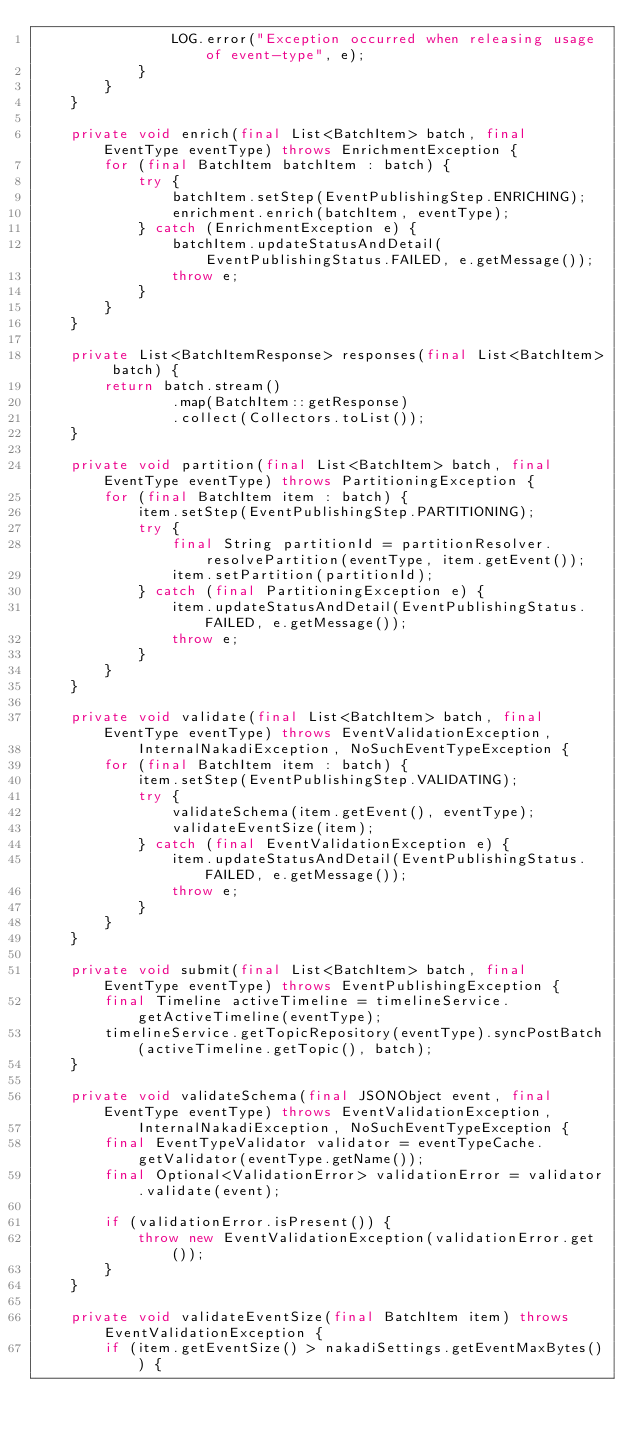Convert code to text. <code><loc_0><loc_0><loc_500><loc_500><_Java_>                LOG.error("Exception occurred when releasing usage of event-type", e);
            }
        }
    }

    private void enrich(final List<BatchItem> batch, final EventType eventType) throws EnrichmentException {
        for (final BatchItem batchItem : batch) {
            try {
                batchItem.setStep(EventPublishingStep.ENRICHING);
                enrichment.enrich(batchItem, eventType);
            } catch (EnrichmentException e) {
                batchItem.updateStatusAndDetail(EventPublishingStatus.FAILED, e.getMessage());
                throw e;
            }
        }
    }

    private List<BatchItemResponse> responses(final List<BatchItem> batch) {
        return batch.stream()
                .map(BatchItem::getResponse)
                .collect(Collectors.toList());
    }

    private void partition(final List<BatchItem> batch, final EventType eventType) throws PartitioningException {
        for (final BatchItem item : batch) {
            item.setStep(EventPublishingStep.PARTITIONING);
            try {
                final String partitionId = partitionResolver.resolvePartition(eventType, item.getEvent());
                item.setPartition(partitionId);
            } catch (final PartitioningException e) {
                item.updateStatusAndDetail(EventPublishingStatus.FAILED, e.getMessage());
                throw e;
            }
        }
    }

    private void validate(final List<BatchItem> batch, final EventType eventType) throws EventValidationException,
            InternalNakadiException, NoSuchEventTypeException {
        for (final BatchItem item : batch) {
            item.setStep(EventPublishingStep.VALIDATING);
            try {
                validateSchema(item.getEvent(), eventType);
                validateEventSize(item);
            } catch (final EventValidationException e) {
                item.updateStatusAndDetail(EventPublishingStatus.FAILED, e.getMessage());
                throw e;
            }
        }
    }

    private void submit(final List<BatchItem> batch, final EventType eventType) throws EventPublishingException {
        final Timeline activeTimeline = timelineService.getActiveTimeline(eventType);
        timelineService.getTopicRepository(eventType).syncPostBatch(activeTimeline.getTopic(), batch);
    }

    private void validateSchema(final JSONObject event, final EventType eventType) throws EventValidationException,
            InternalNakadiException, NoSuchEventTypeException {
        final EventTypeValidator validator = eventTypeCache.getValidator(eventType.getName());
        final Optional<ValidationError> validationError = validator.validate(event);

        if (validationError.isPresent()) {
            throw new EventValidationException(validationError.get());
        }
    }

    private void validateEventSize(final BatchItem item) throws EventValidationException {
        if (item.getEventSize() > nakadiSettings.getEventMaxBytes()) {</code> 